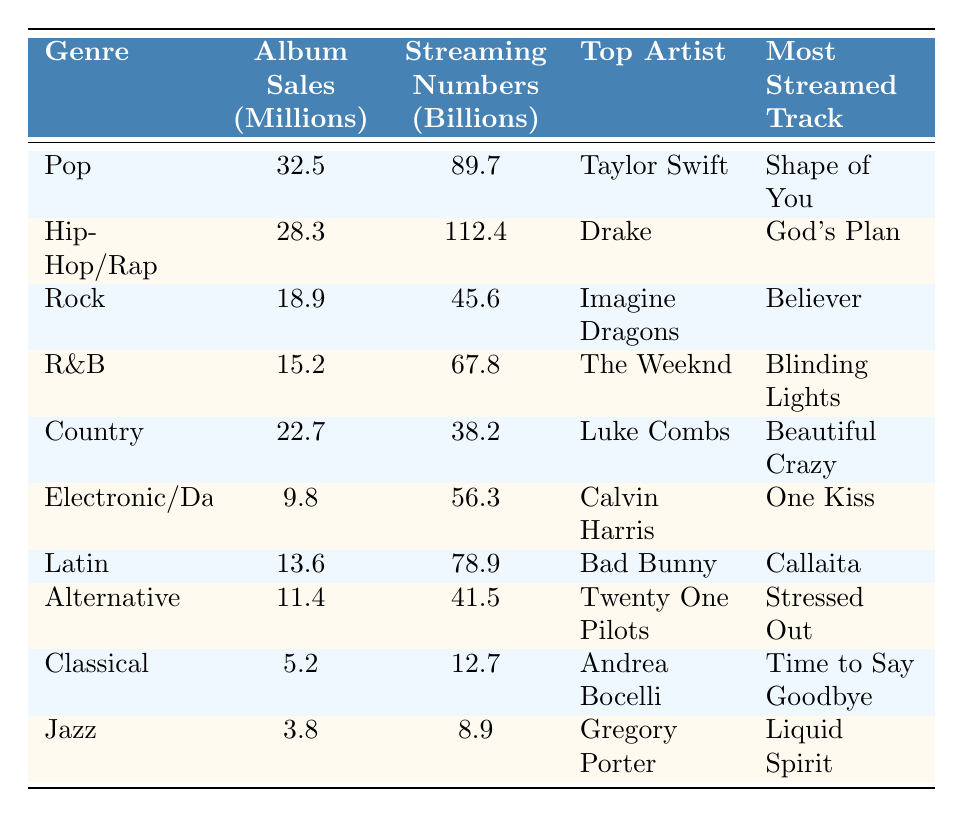What is the genre with the highest album sales? The table lists album sales for each genre, where Pop has the highest sales at 32.5 million.
Answer: Pop Who is the top artist in the Hip-Hop/Rap genre? In the Hip-Hop/Rap category, the table identifies Drake as the top artist.
Answer: Drake What is the most streamed track in the R&B genre? The table indicates that "Blinding Lights" is the most streamed track in the R&B genre.
Answer: Blinding Lights How many million album sales does the Rock genre have? The table shows that the Rock genre has 18.9 million in album sales.
Answer: 18.9 million What is the total album sales for Pop and R&B combined? Pop has 32.5 million and R&B has 15.2 million. Adding these together gives 32.5 + 15.2 = 47.7 million.
Answer: 47.7 million Which genre has the lowest streaming numbers? The table reveals that Jazz has the lowest streaming numbers at 8.9 billion.
Answer: Jazz Is the album sales of Country greater than that of Electronic/Dance? The Country genre has 22.7 million in album sales, while Electronic/Dance has 9.8 million. Since 22.7 is greater than 9.8, the statement is true.
Answer: Yes What is the difference in streaming numbers between Hip-Hop/Rap and Country? The streaming numbers for Hip-Hop/Rap is 112.4 billion, and for Country, it is 38.2 billion. The difference is 112.4 - 38.2 = 74.2 billion.
Answer: 74.2 billion How many genres have album sales of more than 20 million? The genres with more than 20 million in album sales are Pop (32.5 million), Hip-Hop/Rap (28.3 million), and Country (22.7 million), totaling 3 genres.
Answer: 3 What is the average album sales across all genres? The total album sales across all genres can be calculated as 32.5 + 28.3 + 18.9 + 15.2 + 22.7 + 9.8 + 13.6 + 11.4 + 5.2 + 3.8 =  159.0 million. There are 10 genres, so the average is 159.0 / 10 = 15.9 million.
Answer: 15.9 million 